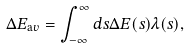Convert formula to latex. <formula><loc_0><loc_0><loc_500><loc_500>\Delta E _ { \mathrm a v } = \int _ { - \infty } ^ { \infty } d s \Delta E ( s ) \lambda ( s ) ,</formula> 